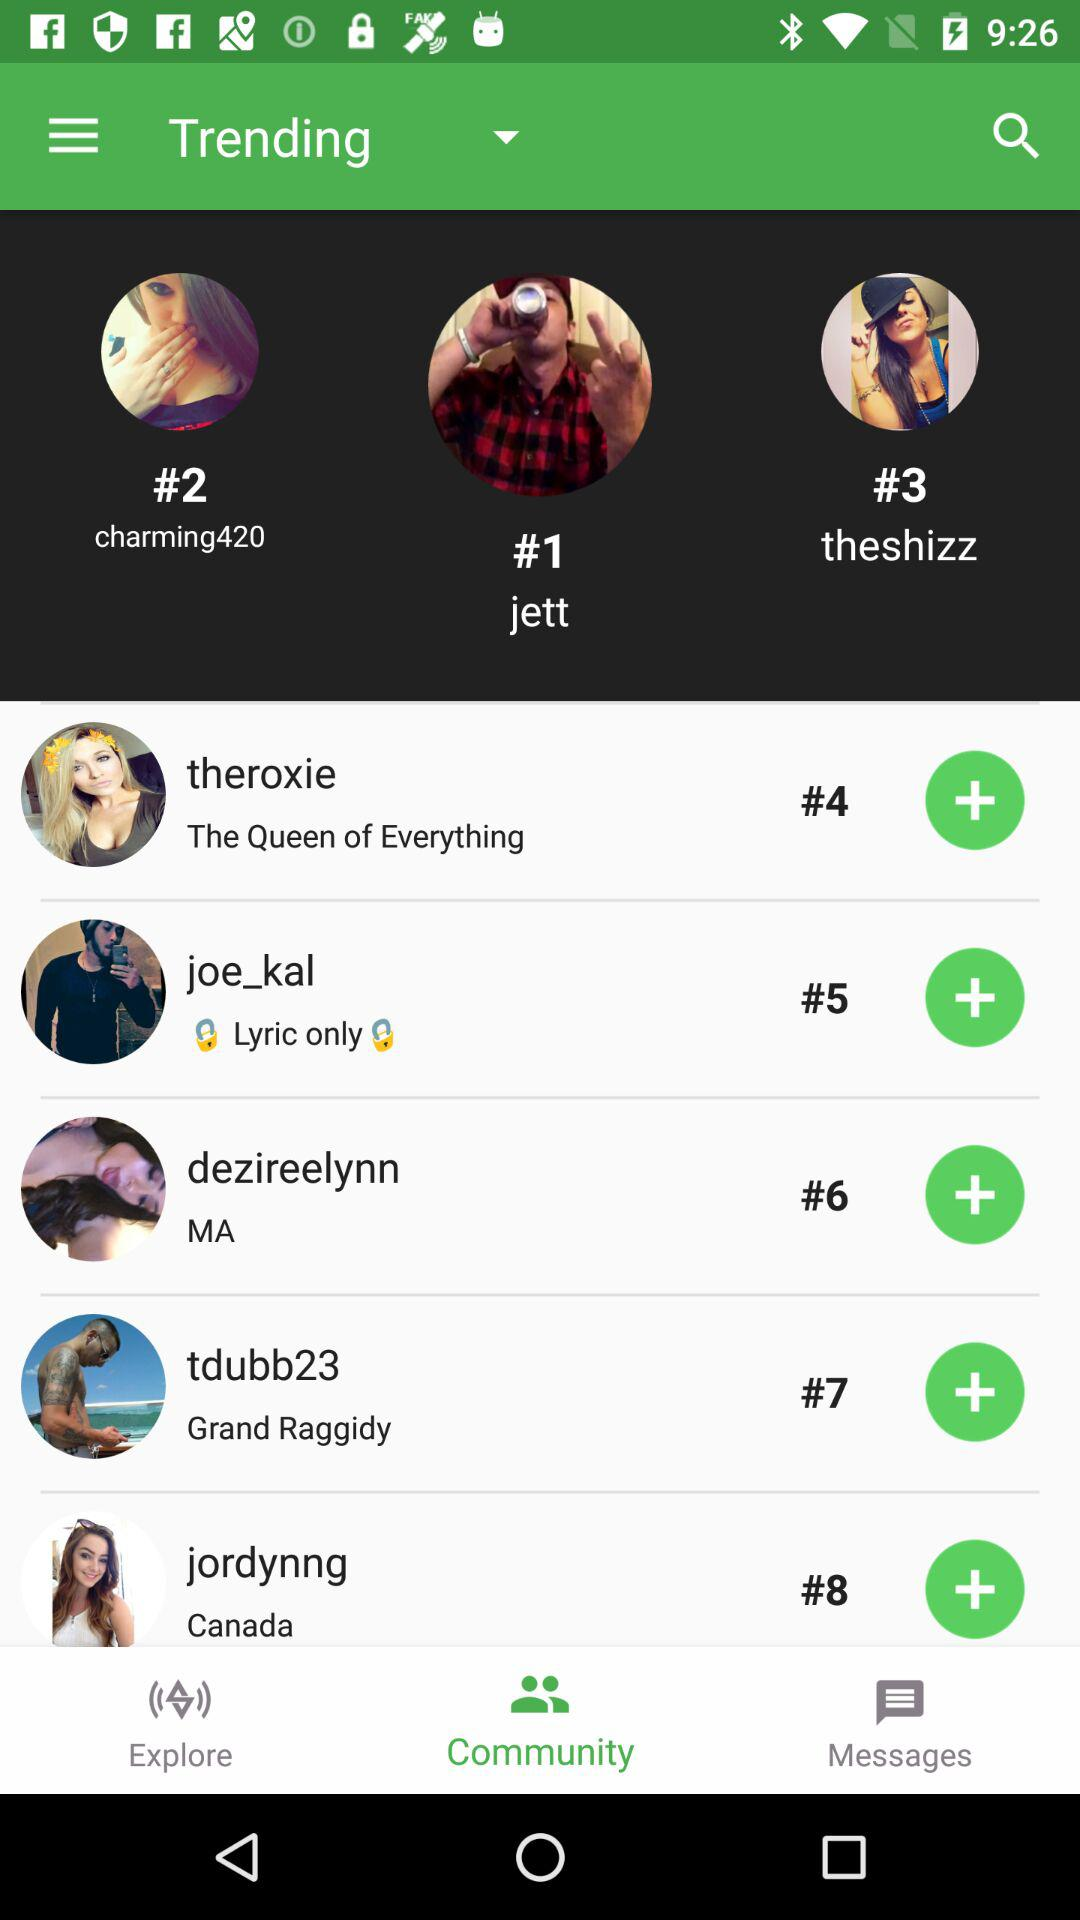Which rank is "jordynng" on? "jordynng" is on the eighth rank. 